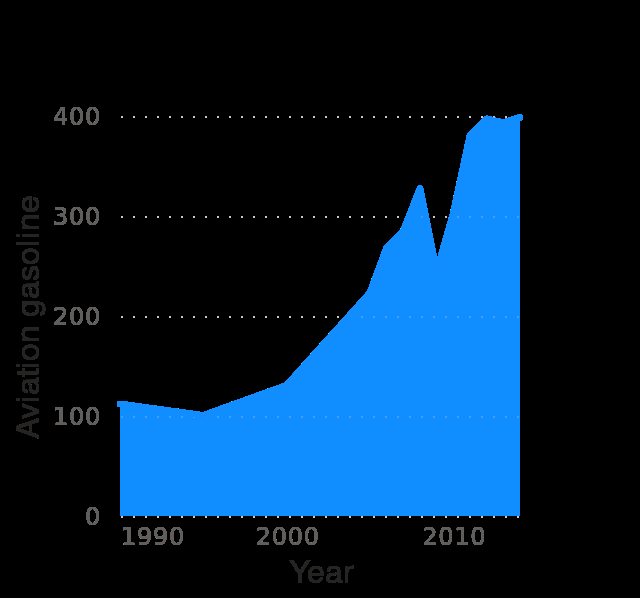<image>
Offer a thorough analysis of the image. the sales price of aviation fuel started to increas from year 2000 reaching 4 times the price of 1990 in 2014. In which year does the data range end? The data range ends in the year 2014. What does the x-axis represent in the diagram? The x-axis in the diagram represents the years ranging from 1990 to 2010, measured on a linear scale. What is the range of the y-axis in the area diagram?  The range of the y-axis in the area diagram is from 0 to 400. 